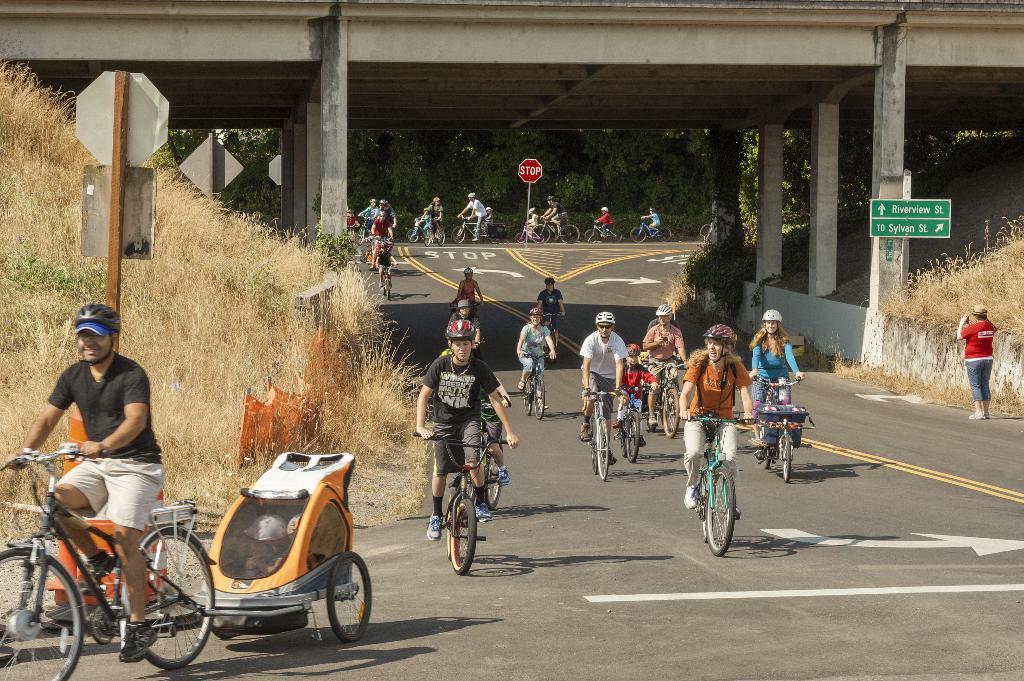In one or two sentences, can you explain what this image depicts? People are riding bicycles under a bridge. 